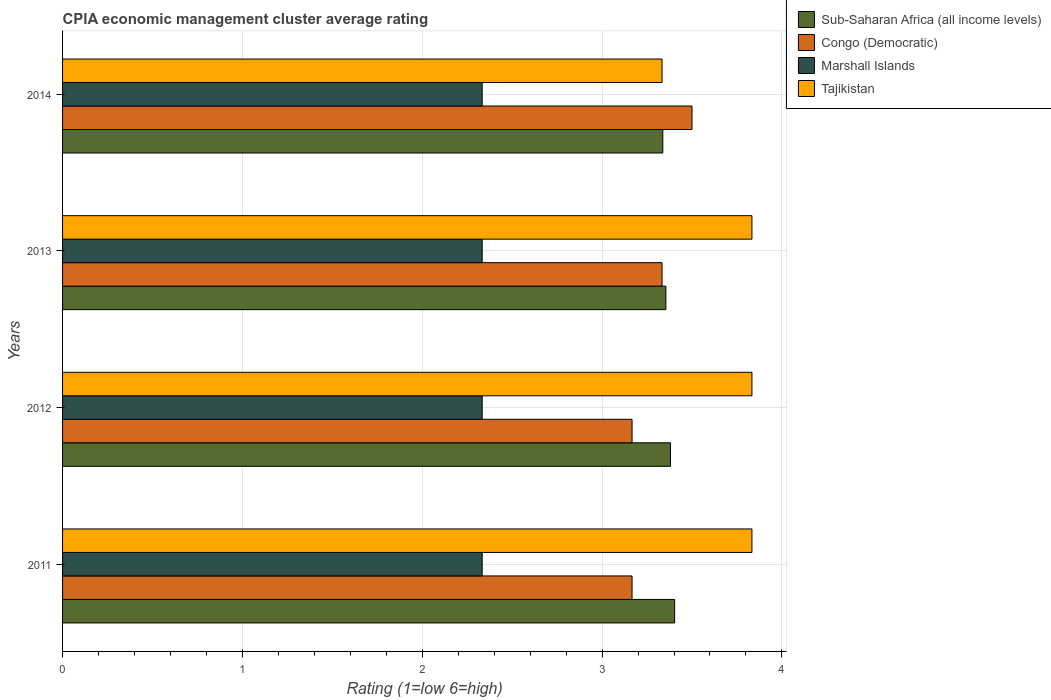How many different coloured bars are there?
Offer a very short reply. 4. Are the number of bars per tick equal to the number of legend labels?
Your response must be concise. Yes. Are the number of bars on each tick of the Y-axis equal?
Provide a succinct answer. Yes. How many bars are there on the 3rd tick from the bottom?
Your response must be concise. 4. What is the label of the 4th group of bars from the top?
Your response must be concise. 2011. What is the CPIA rating in Sub-Saharan Africa (all income levels) in 2012?
Provide a succinct answer. 3.38. Across all years, what is the maximum CPIA rating in Tajikistan?
Offer a terse response. 3.83. Across all years, what is the minimum CPIA rating in Congo (Democratic)?
Your response must be concise. 3.17. What is the total CPIA rating in Marshall Islands in the graph?
Offer a terse response. 9.33. What is the difference between the CPIA rating in Congo (Democratic) in 2012 and that in 2013?
Provide a short and direct response. -0.17. What is the difference between the CPIA rating in Sub-Saharan Africa (all income levels) in 2011 and the CPIA rating in Congo (Democratic) in 2012?
Ensure brevity in your answer.  0.24. What is the average CPIA rating in Sub-Saharan Africa (all income levels) per year?
Offer a terse response. 3.37. In the year 2011, what is the difference between the CPIA rating in Tajikistan and CPIA rating in Sub-Saharan Africa (all income levels)?
Provide a short and direct response. 0.43. In how many years, is the CPIA rating in Sub-Saharan Africa (all income levels) greater than 0.6000000000000001 ?
Offer a very short reply. 4. What is the ratio of the CPIA rating in Congo (Democratic) in 2012 to that in 2013?
Your response must be concise. 0.95. Is the CPIA rating in Tajikistan in 2012 less than that in 2013?
Provide a short and direct response. No. What is the difference between the highest and the second highest CPIA rating in Sub-Saharan Africa (all income levels)?
Make the answer very short. 0.02. What is the difference between the highest and the lowest CPIA rating in Sub-Saharan Africa (all income levels)?
Provide a short and direct response. 0.07. In how many years, is the CPIA rating in Marshall Islands greater than the average CPIA rating in Marshall Islands taken over all years?
Make the answer very short. 3. Is the sum of the CPIA rating in Congo (Democratic) in 2012 and 2013 greater than the maximum CPIA rating in Marshall Islands across all years?
Make the answer very short. Yes. Is it the case that in every year, the sum of the CPIA rating in Marshall Islands and CPIA rating in Congo (Democratic) is greater than the sum of CPIA rating in Tajikistan and CPIA rating in Sub-Saharan Africa (all income levels)?
Keep it short and to the point. No. What does the 1st bar from the top in 2014 represents?
Offer a terse response. Tajikistan. What does the 2nd bar from the bottom in 2011 represents?
Provide a succinct answer. Congo (Democratic). How many bars are there?
Your answer should be compact. 16. Are all the bars in the graph horizontal?
Offer a terse response. Yes. How many years are there in the graph?
Offer a terse response. 4. What is the difference between two consecutive major ticks on the X-axis?
Offer a very short reply. 1. Does the graph contain any zero values?
Ensure brevity in your answer.  No. How many legend labels are there?
Keep it short and to the point. 4. What is the title of the graph?
Ensure brevity in your answer.  CPIA economic management cluster average rating. Does "Indonesia" appear as one of the legend labels in the graph?
Your response must be concise. No. What is the label or title of the X-axis?
Your answer should be very brief. Rating (1=low 6=high). What is the label or title of the Y-axis?
Your answer should be very brief. Years. What is the Rating (1=low 6=high) of Sub-Saharan Africa (all income levels) in 2011?
Your answer should be compact. 3.4. What is the Rating (1=low 6=high) of Congo (Democratic) in 2011?
Your answer should be very brief. 3.17. What is the Rating (1=low 6=high) of Marshall Islands in 2011?
Your answer should be compact. 2.33. What is the Rating (1=low 6=high) in Tajikistan in 2011?
Your response must be concise. 3.83. What is the Rating (1=low 6=high) of Sub-Saharan Africa (all income levels) in 2012?
Your answer should be compact. 3.38. What is the Rating (1=low 6=high) of Congo (Democratic) in 2012?
Offer a very short reply. 3.17. What is the Rating (1=low 6=high) in Marshall Islands in 2012?
Your answer should be very brief. 2.33. What is the Rating (1=low 6=high) of Tajikistan in 2012?
Offer a very short reply. 3.83. What is the Rating (1=low 6=high) in Sub-Saharan Africa (all income levels) in 2013?
Provide a short and direct response. 3.35. What is the Rating (1=low 6=high) of Congo (Democratic) in 2013?
Your answer should be compact. 3.33. What is the Rating (1=low 6=high) in Marshall Islands in 2013?
Your answer should be compact. 2.33. What is the Rating (1=low 6=high) in Tajikistan in 2013?
Your answer should be very brief. 3.83. What is the Rating (1=low 6=high) of Sub-Saharan Africa (all income levels) in 2014?
Your answer should be compact. 3.34. What is the Rating (1=low 6=high) in Marshall Islands in 2014?
Offer a terse response. 2.33. What is the Rating (1=low 6=high) in Tajikistan in 2014?
Your answer should be very brief. 3.33. Across all years, what is the maximum Rating (1=low 6=high) of Sub-Saharan Africa (all income levels)?
Give a very brief answer. 3.4. Across all years, what is the maximum Rating (1=low 6=high) of Marshall Islands?
Offer a terse response. 2.33. Across all years, what is the maximum Rating (1=low 6=high) of Tajikistan?
Ensure brevity in your answer.  3.83. Across all years, what is the minimum Rating (1=low 6=high) of Sub-Saharan Africa (all income levels)?
Make the answer very short. 3.34. Across all years, what is the minimum Rating (1=low 6=high) in Congo (Democratic)?
Your response must be concise. 3.17. Across all years, what is the minimum Rating (1=low 6=high) in Marshall Islands?
Provide a short and direct response. 2.33. Across all years, what is the minimum Rating (1=low 6=high) in Tajikistan?
Give a very brief answer. 3.33. What is the total Rating (1=low 6=high) of Sub-Saharan Africa (all income levels) in the graph?
Provide a succinct answer. 13.48. What is the total Rating (1=low 6=high) in Congo (Democratic) in the graph?
Make the answer very short. 13.17. What is the total Rating (1=low 6=high) in Marshall Islands in the graph?
Keep it short and to the point. 9.33. What is the total Rating (1=low 6=high) in Tajikistan in the graph?
Give a very brief answer. 14.83. What is the difference between the Rating (1=low 6=high) of Sub-Saharan Africa (all income levels) in 2011 and that in 2012?
Offer a terse response. 0.02. What is the difference between the Rating (1=low 6=high) in Congo (Democratic) in 2011 and that in 2012?
Offer a terse response. 0. What is the difference between the Rating (1=low 6=high) of Sub-Saharan Africa (all income levels) in 2011 and that in 2013?
Offer a terse response. 0.05. What is the difference between the Rating (1=low 6=high) of Congo (Democratic) in 2011 and that in 2013?
Give a very brief answer. -0.17. What is the difference between the Rating (1=low 6=high) of Sub-Saharan Africa (all income levels) in 2011 and that in 2014?
Keep it short and to the point. 0.07. What is the difference between the Rating (1=low 6=high) of Sub-Saharan Africa (all income levels) in 2012 and that in 2013?
Your answer should be very brief. 0.03. What is the difference between the Rating (1=low 6=high) of Marshall Islands in 2012 and that in 2013?
Provide a short and direct response. 0. What is the difference between the Rating (1=low 6=high) in Sub-Saharan Africa (all income levels) in 2012 and that in 2014?
Your answer should be compact. 0.04. What is the difference between the Rating (1=low 6=high) in Congo (Democratic) in 2012 and that in 2014?
Offer a very short reply. -0.33. What is the difference between the Rating (1=low 6=high) in Marshall Islands in 2012 and that in 2014?
Ensure brevity in your answer.  0. What is the difference between the Rating (1=low 6=high) of Tajikistan in 2012 and that in 2014?
Offer a terse response. 0.5. What is the difference between the Rating (1=low 6=high) in Sub-Saharan Africa (all income levels) in 2013 and that in 2014?
Make the answer very short. 0.02. What is the difference between the Rating (1=low 6=high) in Congo (Democratic) in 2013 and that in 2014?
Offer a terse response. -0.17. What is the difference between the Rating (1=low 6=high) of Tajikistan in 2013 and that in 2014?
Make the answer very short. 0.5. What is the difference between the Rating (1=low 6=high) of Sub-Saharan Africa (all income levels) in 2011 and the Rating (1=low 6=high) of Congo (Democratic) in 2012?
Provide a short and direct response. 0.24. What is the difference between the Rating (1=low 6=high) of Sub-Saharan Africa (all income levels) in 2011 and the Rating (1=low 6=high) of Marshall Islands in 2012?
Ensure brevity in your answer.  1.07. What is the difference between the Rating (1=low 6=high) in Sub-Saharan Africa (all income levels) in 2011 and the Rating (1=low 6=high) in Tajikistan in 2012?
Make the answer very short. -0.43. What is the difference between the Rating (1=low 6=high) in Congo (Democratic) in 2011 and the Rating (1=low 6=high) in Marshall Islands in 2012?
Provide a short and direct response. 0.83. What is the difference between the Rating (1=low 6=high) in Marshall Islands in 2011 and the Rating (1=low 6=high) in Tajikistan in 2012?
Keep it short and to the point. -1.5. What is the difference between the Rating (1=low 6=high) of Sub-Saharan Africa (all income levels) in 2011 and the Rating (1=low 6=high) of Congo (Democratic) in 2013?
Provide a short and direct response. 0.07. What is the difference between the Rating (1=low 6=high) of Sub-Saharan Africa (all income levels) in 2011 and the Rating (1=low 6=high) of Marshall Islands in 2013?
Your answer should be compact. 1.07. What is the difference between the Rating (1=low 6=high) in Sub-Saharan Africa (all income levels) in 2011 and the Rating (1=low 6=high) in Tajikistan in 2013?
Offer a very short reply. -0.43. What is the difference between the Rating (1=low 6=high) in Congo (Democratic) in 2011 and the Rating (1=low 6=high) in Tajikistan in 2013?
Provide a succinct answer. -0.67. What is the difference between the Rating (1=low 6=high) in Marshall Islands in 2011 and the Rating (1=low 6=high) in Tajikistan in 2013?
Offer a terse response. -1.5. What is the difference between the Rating (1=low 6=high) of Sub-Saharan Africa (all income levels) in 2011 and the Rating (1=low 6=high) of Congo (Democratic) in 2014?
Your answer should be compact. -0.1. What is the difference between the Rating (1=low 6=high) of Sub-Saharan Africa (all income levels) in 2011 and the Rating (1=low 6=high) of Marshall Islands in 2014?
Your answer should be very brief. 1.07. What is the difference between the Rating (1=low 6=high) of Sub-Saharan Africa (all income levels) in 2011 and the Rating (1=low 6=high) of Tajikistan in 2014?
Your answer should be compact. 0.07. What is the difference between the Rating (1=low 6=high) of Congo (Democratic) in 2011 and the Rating (1=low 6=high) of Tajikistan in 2014?
Give a very brief answer. -0.17. What is the difference between the Rating (1=low 6=high) of Sub-Saharan Africa (all income levels) in 2012 and the Rating (1=low 6=high) of Congo (Democratic) in 2013?
Offer a terse response. 0.05. What is the difference between the Rating (1=low 6=high) of Sub-Saharan Africa (all income levels) in 2012 and the Rating (1=low 6=high) of Marshall Islands in 2013?
Provide a succinct answer. 1.05. What is the difference between the Rating (1=low 6=high) in Sub-Saharan Africa (all income levels) in 2012 and the Rating (1=low 6=high) in Tajikistan in 2013?
Keep it short and to the point. -0.45. What is the difference between the Rating (1=low 6=high) in Sub-Saharan Africa (all income levels) in 2012 and the Rating (1=low 6=high) in Congo (Democratic) in 2014?
Offer a terse response. -0.12. What is the difference between the Rating (1=low 6=high) of Sub-Saharan Africa (all income levels) in 2012 and the Rating (1=low 6=high) of Marshall Islands in 2014?
Offer a very short reply. 1.05. What is the difference between the Rating (1=low 6=high) in Sub-Saharan Africa (all income levels) in 2012 and the Rating (1=low 6=high) in Tajikistan in 2014?
Your response must be concise. 0.05. What is the difference between the Rating (1=low 6=high) of Congo (Democratic) in 2012 and the Rating (1=low 6=high) of Marshall Islands in 2014?
Keep it short and to the point. 0.83. What is the difference between the Rating (1=low 6=high) of Congo (Democratic) in 2012 and the Rating (1=low 6=high) of Tajikistan in 2014?
Offer a very short reply. -0.17. What is the difference between the Rating (1=low 6=high) of Sub-Saharan Africa (all income levels) in 2013 and the Rating (1=low 6=high) of Congo (Democratic) in 2014?
Provide a succinct answer. -0.15. What is the difference between the Rating (1=low 6=high) of Sub-Saharan Africa (all income levels) in 2013 and the Rating (1=low 6=high) of Marshall Islands in 2014?
Your answer should be compact. 1.02. What is the difference between the Rating (1=low 6=high) in Sub-Saharan Africa (all income levels) in 2013 and the Rating (1=low 6=high) in Tajikistan in 2014?
Make the answer very short. 0.02. What is the difference between the Rating (1=low 6=high) of Marshall Islands in 2013 and the Rating (1=low 6=high) of Tajikistan in 2014?
Provide a succinct answer. -1. What is the average Rating (1=low 6=high) of Sub-Saharan Africa (all income levels) per year?
Ensure brevity in your answer.  3.37. What is the average Rating (1=low 6=high) in Congo (Democratic) per year?
Your answer should be compact. 3.29. What is the average Rating (1=low 6=high) in Marshall Islands per year?
Offer a terse response. 2.33. What is the average Rating (1=low 6=high) in Tajikistan per year?
Your answer should be compact. 3.71. In the year 2011, what is the difference between the Rating (1=low 6=high) in Sub-Saharan Africa (all income levels) and Rating (1=low 6=high) in Congo (Democratic)?
Offer a very short reply. 0.24. In the year 2011, what is the difference between the Rating (1=low 6=high) in Sub-Saharan Africa (all income levels) and Rating (1=low 6=high) in Marshall Islands?
Provide a short and direct response. 1.07. In the year 2011, what is the difference between the Rating (1=low 6=high) in Sub-Saharan Africa (all income levels) and Rating (1=low 6=high) in Tajikistan?
Ensure brevity in your answer.  -0.43. In the year 2011, what is the difference between the Rating (1=low 6=high) in Congo (Democratic) and Rating (1=low 6=high) in Tajikistan?
Offer a very short reply. -0.67. In the year 2011, what is the difference between the Rating (1=low 6=high) in Marshall Islands and Rating (1=low 6=high) in Tajikistan?
Provide a succinct answer. -1.5. In the year 2012, what is the difference between the Rating (1=low 6=high) of Sub-Saharan Africa (all income levels) and Rating (1=low 6=high) of Congo (Democratic)?
Your response must be concise. 0.21. In the year 2012, what is the difference between the Rating (1=low 6=high) in Sub-Saharan Africa (all income levels) and Rating (1=low 6=high) in Marshall Islands?
Keep it short and to the point. 1.05. In the year 2012, what is the difference between the Rating (1=low 6=high) in Sub-Saharan Africa (all income levels) and Rating (1=low 6=high) in Tajikistan?
Offer a terse response. -0.45. In the year 2012, what is the difference between the Rating (1=low 6=high) of Marshall Islands and Rating (1=low 6=high) of Tajikistan?
Offer a terse response. -1.5. In the year 2013, what is the difference between the Rating (1=low 6=high) in Sub-Saharan Africa (all income levels) and Rating (1=low 6=high) in Congo (Democratic)?
Ensure brevity in your answer.  0.02. In the year 2013, what is the difference between the Rating (1=low 6=high) of Sub-Saharan Africa (all income levels) and Rating (1=low 6=high) of Marshall Islands?
Give a very brief answer. 1.02. In the year 2013, what is the difference between the Rating (1=low 6=high) of Sub-Saharan Africa (all income levels) and Rating (1=low 6=high) of Tajikistan?
Your response must be concise. -0.48. In the year 2014, what is the difference between the Rating (1=low 6=high) of Sub-Saharan Africa (all income levels) and Rating (1=low 6=high) of Congo (Democratic)?
Keep it short and to the point. -0.16. In the year 2014, what is the difference between the Rating (1=low 6=high) in Sub-Saharan Africa (all income levels) and Rating (1=low 6=high) in Marshall Islands?
Keep it short and to the point. 1. In the year 2014, what is the difference between the Rating (1=low 6=high) in Sub-Saharan Africa (all income levels) and Rating (1=low 6=high) in Tajikistan?
Keep it short and to the point. 0. In the year 2014, what is the difference between the Rating (1=low 6=high) in Congo (Democratic) and Rating (1=low 6=high) in Tajikistan?
Your response must be concise. 0.17. In the year 2014, what is the difference between the Rating (1=low 6=high) in Marshall Islands and Rating (1=low 6=high) in Tajikistan?
Ensure brevity in your answer.  -1. What is the ratio of the Rating (1=low 6=high) of Sub-Saharan Africa (all income levels) in 2011 to that in 2012?
Provide a succinct answer. 1.01. What is the ratio of the Rating (1=low 6=high) in Sub-Saharan Africa (all income levels) in 2011 to that in 2013?
Your response must be concise. 1.01. What is the ratio of the Rating (1=low 6=high) in Congo (Democratic) in 2011 to that in 2013?
Provide a short and direct response. 0.95. What is the ratio of the Rating (1=low 6=high) of Sub-Saharan Africa (all income levels) in 2011 to that in 2014?
Keep it short and to the point. 1.02. What is the ratio of the Rating (1=low 6=high) of Congo (Democratic) in 2011 to that in 2014?
Provide a short and direct response. 0.9. What is the ratio of the Rating (1=low 6=high) in Tajikistan in 2011 to that in 2014?
Your answer should be very brief. 1.15. What is the ratio of the Rating (1=low 6=high) in Sub-Saharan Africa (all income levels) in 2012 to that in 2013?
Provide a succinct answer. 1.01. What is the ratio of the Rating (1=low 6=high) in Congo (Democratic) in 2012 to that in 2013?
Offer a terse response. 0.95. What is the ratio of the Rating (1=low 6=high) of Sub-Saharan Africa (all income levels) in 2012 to that in 2014?
Provide a short and direct response. 1.01. What is the ratio of the Rating (1=low 6=high) in Congo (Democratic) in 2012 to that in 2014?
Provide a succinct answer. 0.9. What is the ratio of the Rating (1=low 6=high) in Tajikistan in 2012 to that in 2014?
Your answer should be compact. 1.15. What is the ratio of the Rating (1=low 6=high) of Congo (Democratic) in 2013 to that in 2014?
Provide a short and direct response. 0.95. What is the ratio of the Rating (1=low 6=high) of Marshall Islands in 2013 to that in 2014?
Your response must be concise. 1. What is the ratio of the Rating (1=low 6=high) in Tajikistan in 2013 to that in 2014?
Provide a succinct answer. 1.15. What is the difference between the highest and the second highest Rating (1=low 6=high) of Sub-Saharan Africa (all income levels)?
Keep it short and to the point. 0.02. What is the difference between the highest and the second highest Rating (1=low 6=high) in Congo (Democratic)?
Keep it short and to the point. 0.17. What is the difference between the highest and the lowest Rating (1=low 6=high) of Sub-Saharan Africa (all income levels)?
Keep it short and to the point. 0.07. What is the difference between the highest and the lowest Rating (1=low 6=high) in Tajikistan?
Your answer should be compact. 0.5. 